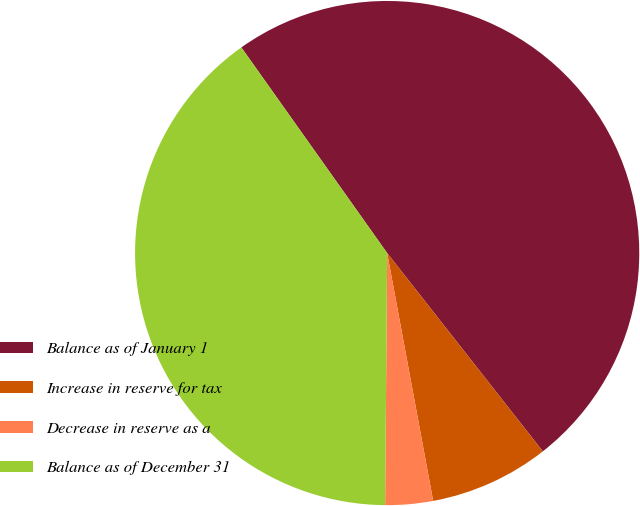<chart> <loc_0><loc_0><loc_500><loc_500><pie_chart><fcel>Balance as of January 1<fcel>Increase in reserve for tax<fcel>Decrease in reserve as a<fcel>Balance as of December 31<nl><fcel>49.22%<fcel>7.67%<fcel>3.05%<fcel>40.05%<nl></chart> 